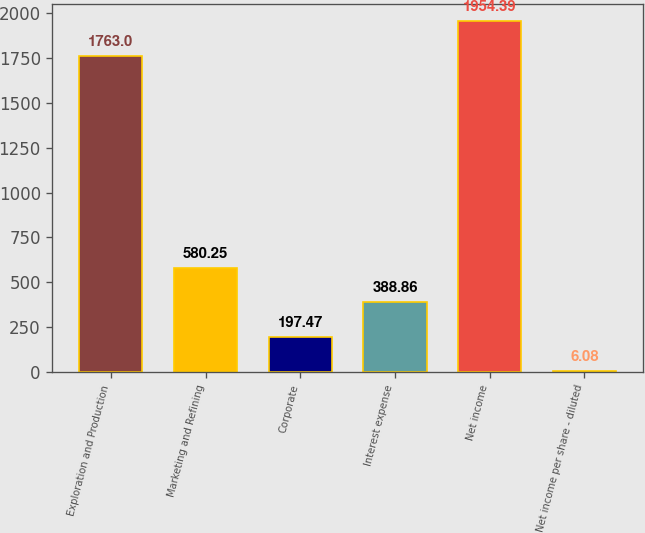<chart> <loc_0><loc_0><loc_500><loc_500><bar_chart><fcel>Exploration and Production<fcel>Marketing and Refining<fcel>Corporate<fcel>Interest expense<fcel>Net income<fcel>Net income per share - diluted<nl><fcel>1763<fcel>580.25<fcel>197.47<fcel>388.86<fcel>1954.39<fcel>6.08<nl></chart> 